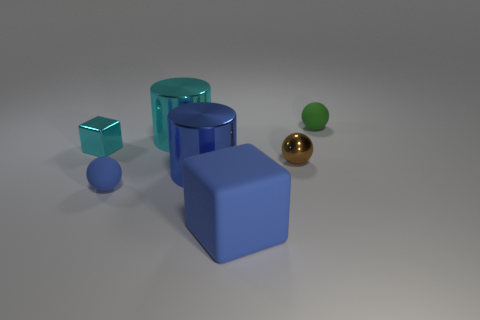Add 2 green shiny cylinders. How many objects exist? 9 Subtract all cylinders. How many objects are left? 5 Add 6 big blocks. How many big blocks are left? 7 Add 2 big blue metallic objects. How many big blue metallic objects exist? 3 Subtract 0 green cylinders. How many objects are left? 7 Subtract all blue objects. Subtract all matte cubes. How many objects are left? 3 